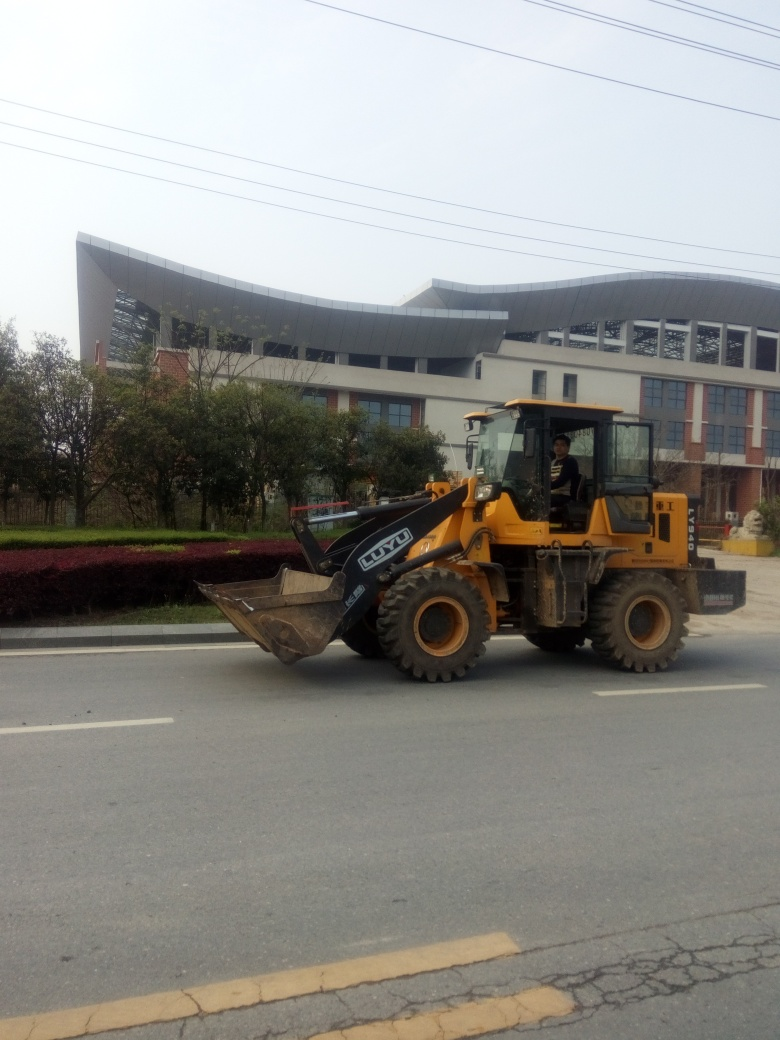What does the setting of this photo suggest about its location? The setting of the photo suggests it is most likely taken on a street within an urban or suburban area. The presence of the front loader on the road hints at some ongoing construction or maintenance work nearby. Additionally, the style of the building and the landscaped vegetation indicate a developed area with some attention to urban planning and design. Is there anything about the vehicle that indicates its use or the work it might be doing? The front loader has a bucket attachment in front, which is commonly used for moving earth or loading loose materials. The fact that it's traveling on the road could suggest it is moving between work sites or potentially clearing debris or materials from the surrounding area. There are no visible signs of construction materials in the bucket, so it could be on its way to or from a task. 